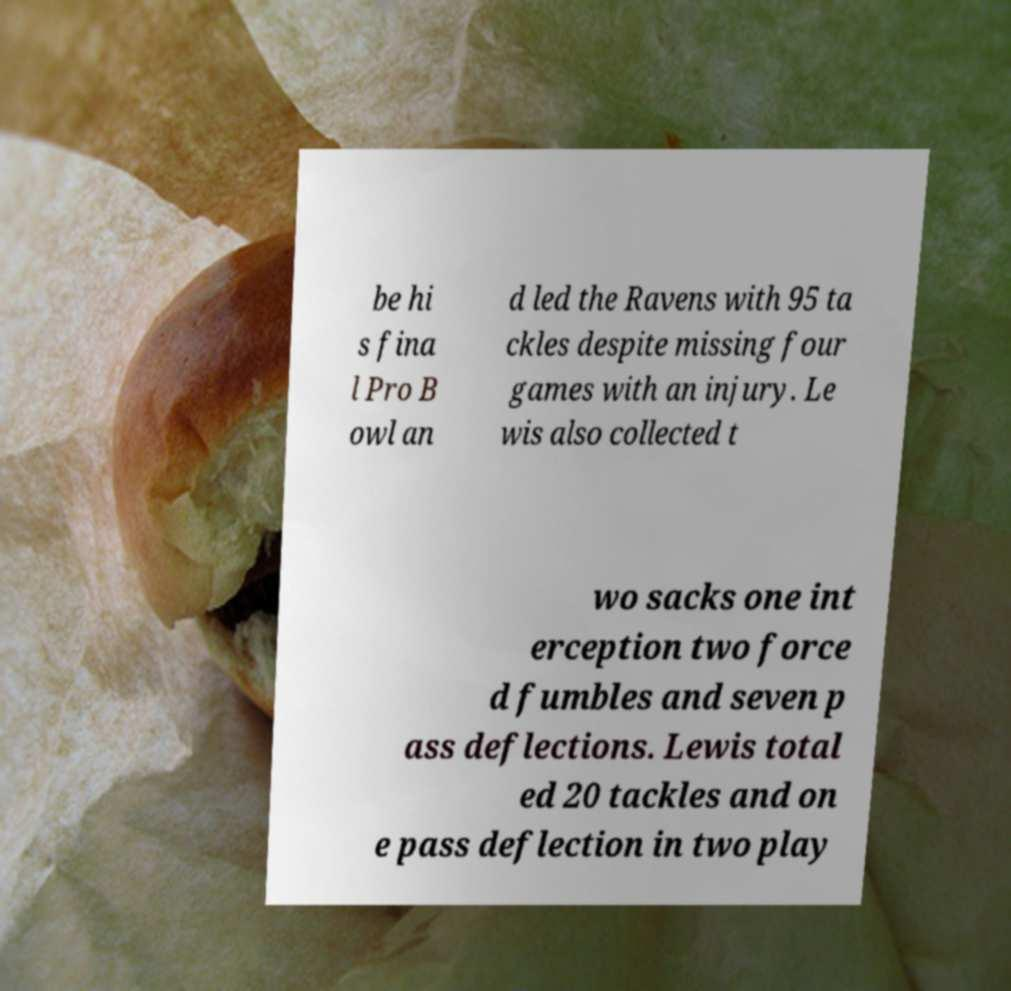Could you extract and type out the text from this image? be hi s fina l Pro B owl an d led the Ravens with 95 ta ckles despite missing four games with an injury. Le wis also collected t wo sacks one int erception two force d fumbles and seven p ass deflections. Lewis total ed 20 tackles and on e pass deflection in two play 